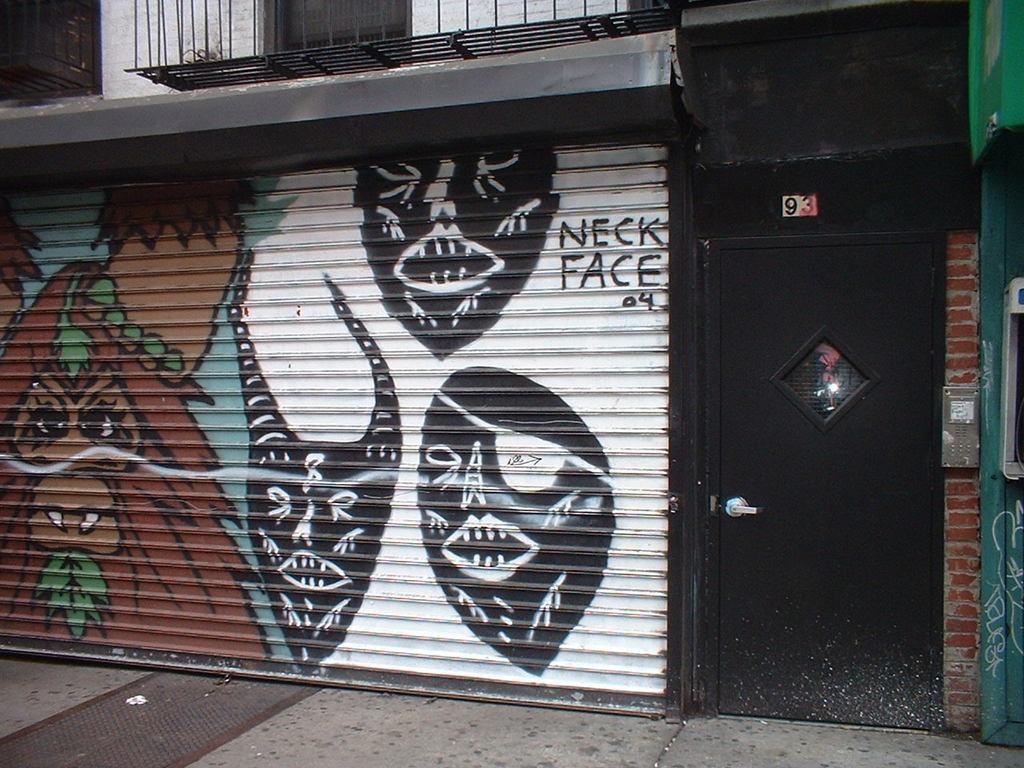Describe this image in one or two sentences. In this image I can see the black colored gate, the rolling shutter which is black, brown, white, green and blue in color and the building. 